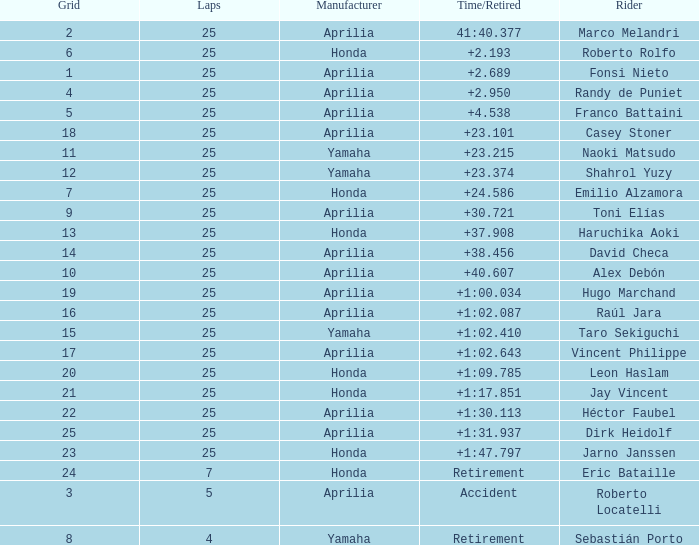Which Laps have a Time/Retired of +23.215, and a Grid larger than 11? None. 